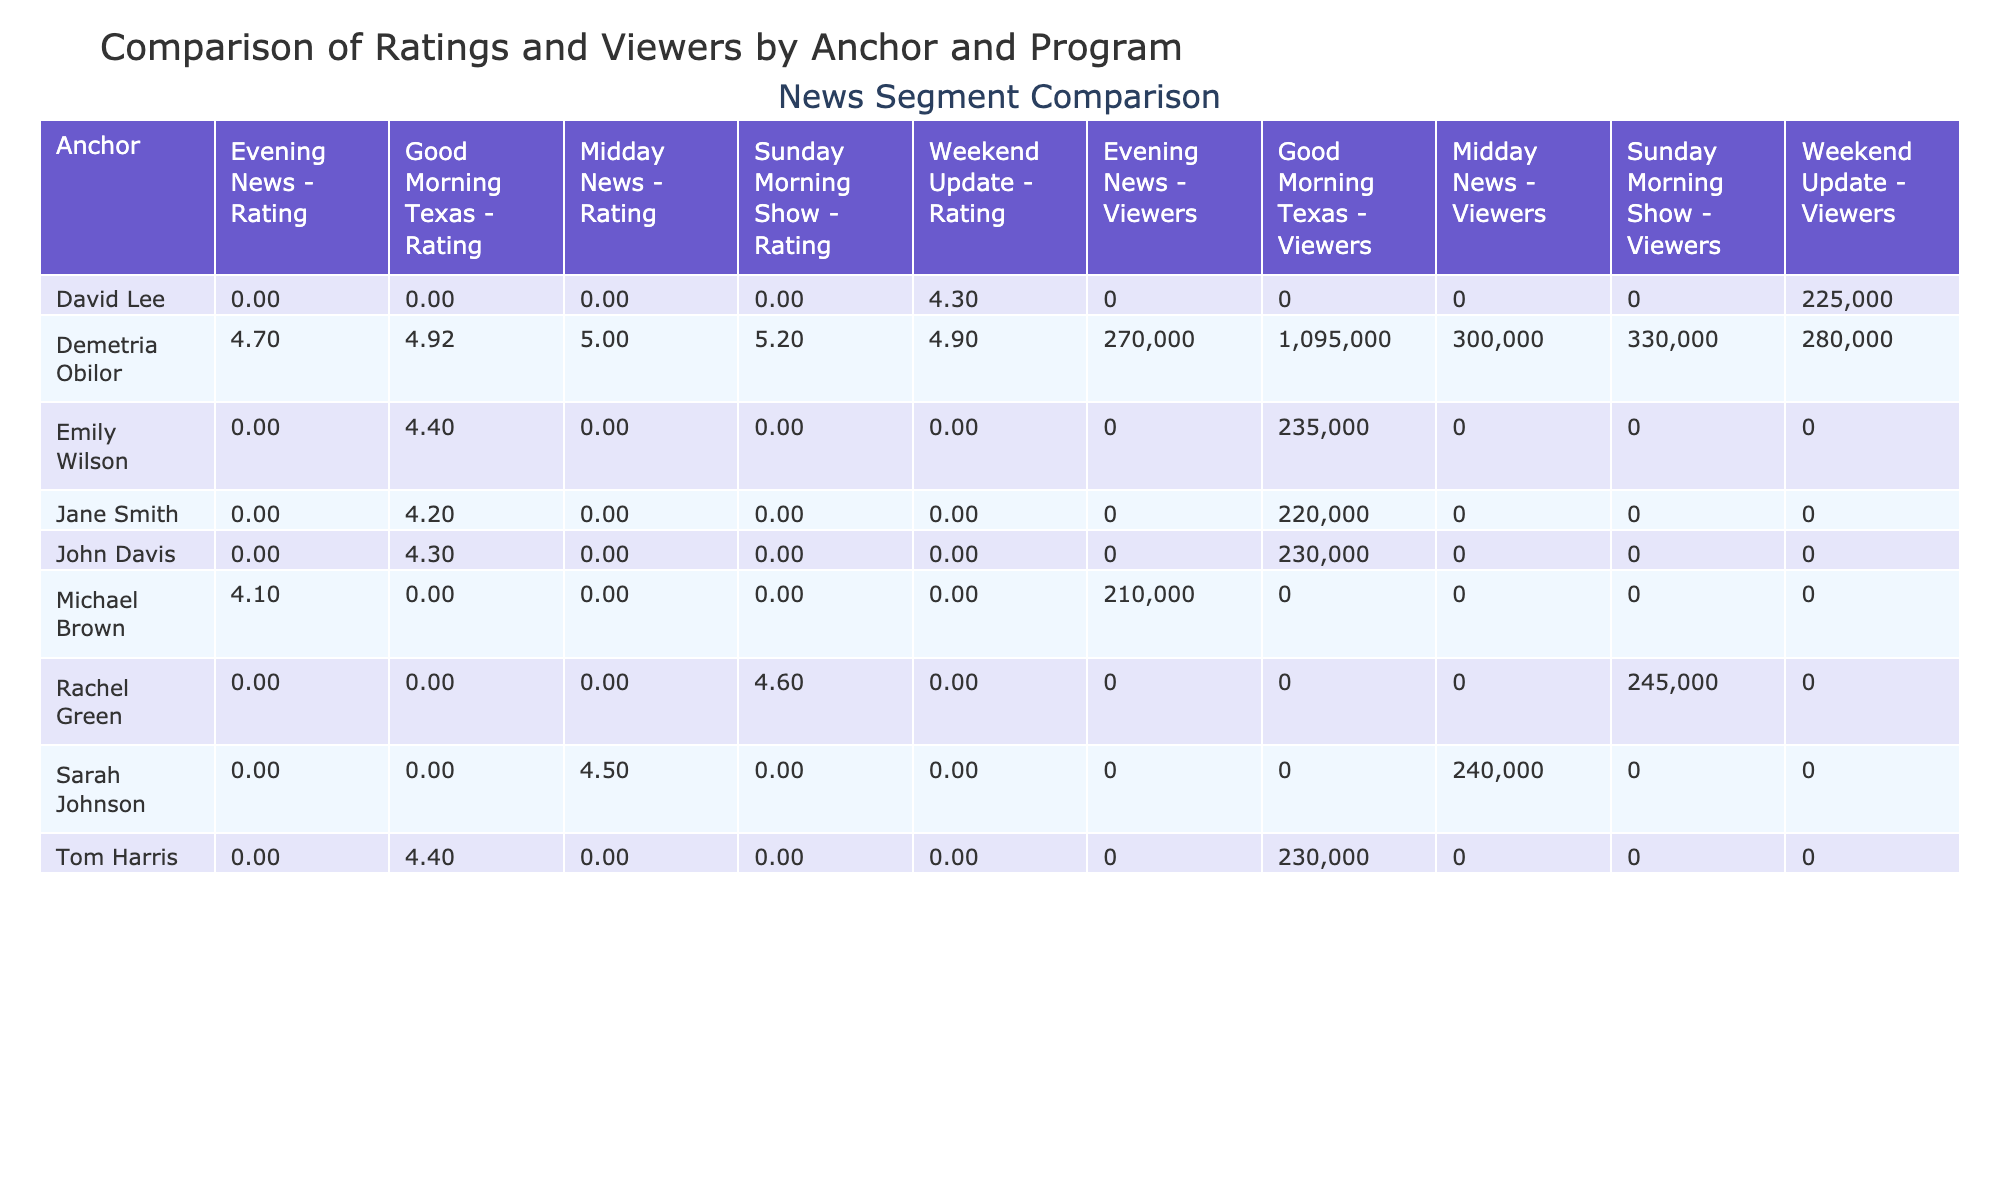What is the average rating for segments featuring Demetria Obilor? To find the average rating, we will sum the ratings for all segments featuring Demetria Obilor: 4.8, 4.9, 5.0, 4.7, 5.1, 4.9, 5.2, and 4.9. Adding these gives us a total of 39.5. There are 8 segments, so the average rating is 39.5 / 8 = 4.9375, which rounds to 4.94.
Answer: 4.94 Which anchor had the highest rating in their segment? Looking through the ratings for each anchor, we see Demetria Obilor has a highest rating of 5.2 with the Lifestyle Feature segment on May 7. Reviewing other anchors shows that no one else exceeds this rating.
Answer: Demetria Obilor How many viewers did the segment with the highest rating receive, and who was the anchor? The segment with the highest rating is the Lifestyle Feature by Demetria Obilor with a rating of 5.2. Checking its viewers, we find that it received 330,000 viewers.
Answer: 330000 viewers by Demetria Obilor Did any segments by anchors other than Demetria Obilor exceed a rating of 5.0? Reviewing the ratings of segments, we conclude that no segments from other anchors surpassed the rating of 5.0. The highest rating from others is 4.6, which belongs to Rachel Green.
Answer: No What is the total viewership for all the segments hosted by Jane Smith? Checking the segments by Jane Smith, she has one segment on May 1, with a total of 220,000 viewers. Since she only has one segment, the total viewership is simply 220,000.
Answer: 220000 What is the difference in average ratings between Demetria Obilor and Sarah Johnson? First, we calculate the average rating for Demetria Obilor (4.94). For Sarah Johnson, there is only one segment with a rating of 4.5. The difference is 4.94 - 4.5 = 0.44.
Answer: 0.44 How many total viewers did all segments hosted by Demetria Obilor attract? To find total viewers for Demetria Obilor's segments, we sum her viewers: 250,000 + 260,000 + 300,000 + 270,000 + 320,000 + 280,000 + 330,000 + 265,000. This totals to 2,005,000 viewers.
Answer: 2005000 Which program had the highest average rating across all anchors? By examining the ratings, we find that 'Good Morning Texas' ranks the highest. We calculate the average ratings for each program; for Good Morning Texas, averaging: (4.8, 4.2, 4.9, 4.4) gives 4.575. Comparison with other programs like Midday News (4.75), shows Good Morning Texas as the highest.
Answer: Good Morning Texas Which age group watched more segments featuring Demetria Obilor? Demetria Obilor's segments predominantly attracted the 18-34 age group with 5 segments focusing on this demographic segment. In contrast, other segments targeted various ages but none exceed quantity from Demetria's focus group.
Answer: 18-34 age group 